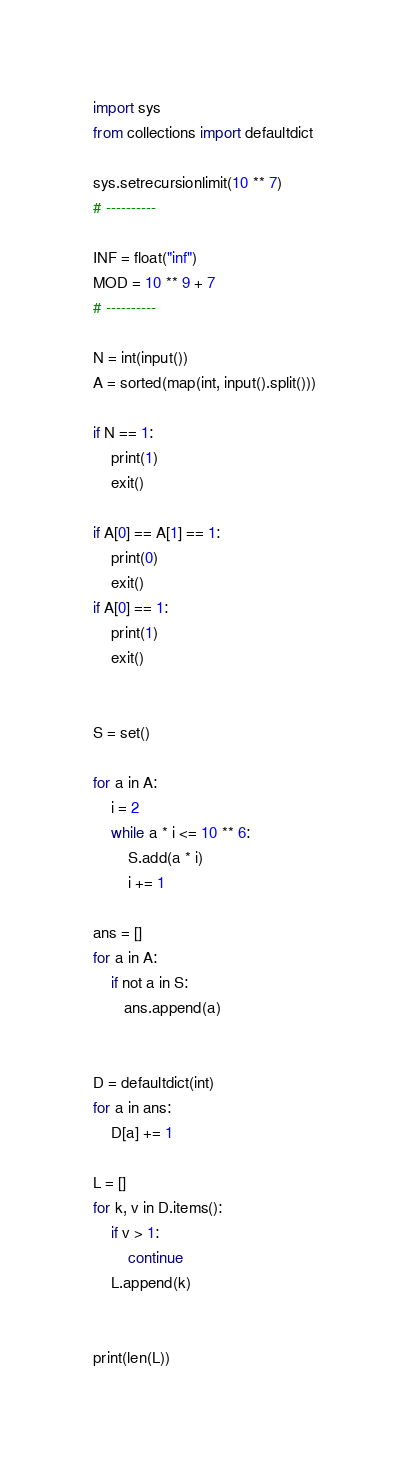<code> <loc_0><loc_0><loc_500><loc_500><_Python_>
import sys
from collections import defaultdict

sys.setrecursionlimit(10 ** 7)
# ----------

INF = float("inf")
MOD = 10 ** 9 + 7
# ----------

N = int(input())
A = sorted(map(int, input().split()))

if N == 1:
    print(1)
    exit()

if A[0] == A[1] == 1:
    print(0)
    exit()
if A[0] == 1:
    print(1)
    exit()


S = set()

for a in A:
    i = 2
    while a * i <= 10 ** 6:
        S.add(a * i)
        i += 1

ans = []
for a in A:
    if not a in S:
       ans.append(a)


D = defaultdict(int)
for a in ans:
    D[a] += 1

L = []
for k, v in D.items():
    if v > 1:
        continue
    L.append(k)


print(len(L))


</code> 